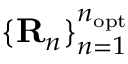Convert formula to latex. <formula><loc_0><loc_0><loc_500><loc_500>\{ { R } _ { n } \} _ { n = 1 } ^ { n _ { o p t } }</formula> 